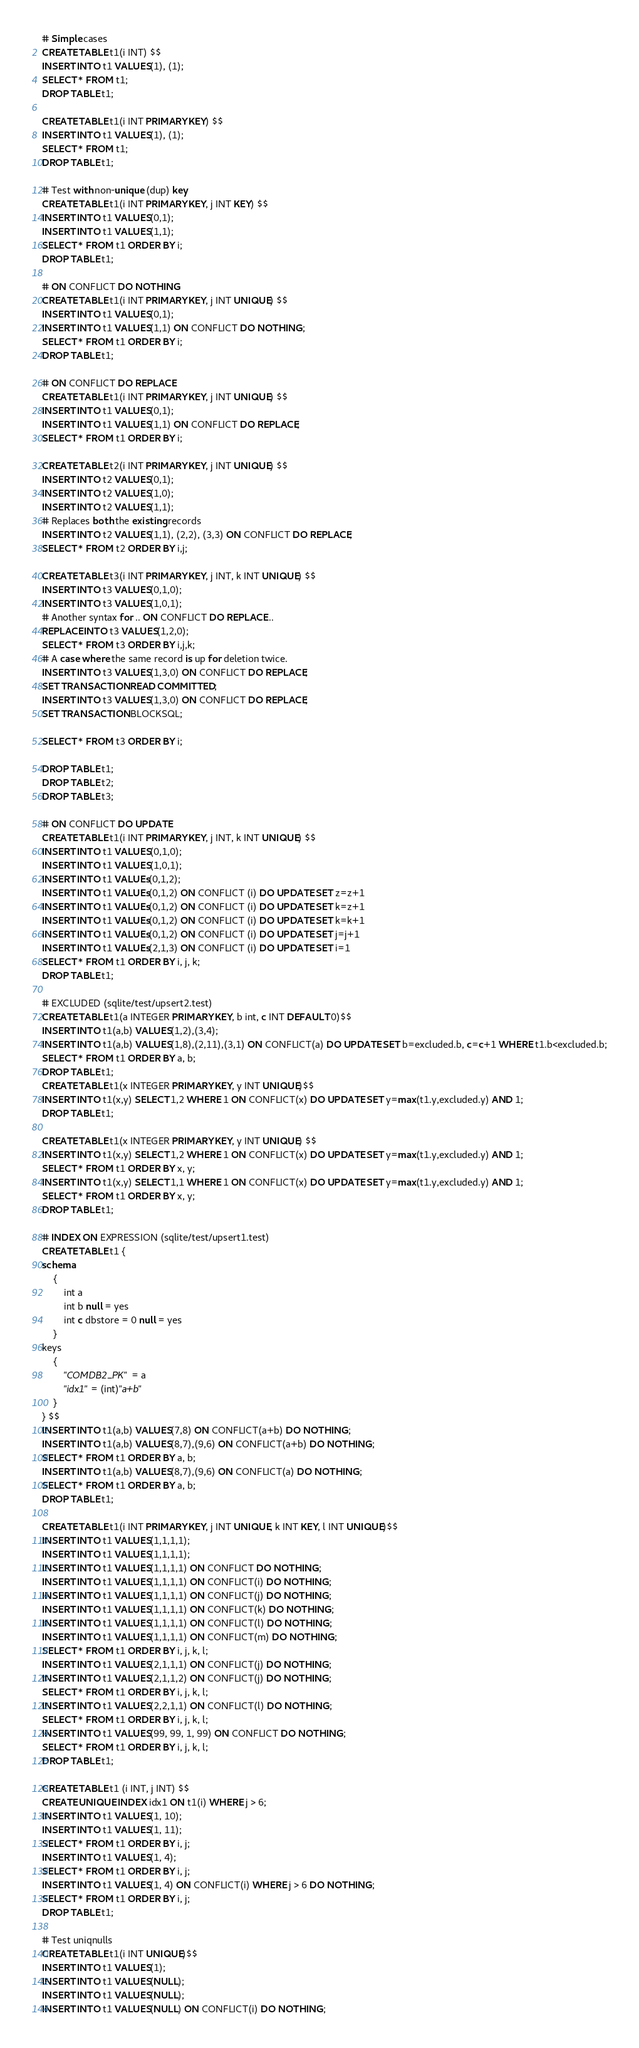<code> <loc_0><loc_0><loc_500><loc_500><_SQL_># Simple cases
CREATE TABLE t1(i INT) $$
INSERT INTO t1 VALUES(1), (1);
SELECT * FROM t1;
DROP TABLE t1;

CREATE TABLE t1(i INT PRIMARY KEY) $$
INSERT INTO t1 VALUES(1), (1);
SELECT * FROM t1;
DROP TABLE t1;

# Test with non-unique (dup) key
CREATE TABLE t1(i INT PRIMARY KEY, j INT KEY) $$
INSERT INTO t1 VALUES(0,1);
INSERT INTO t1 VALUES(1,1);
SELECT * FROM t1 ORDER BY i;
DROP TABLE t1;

# ON CONFLICT DO NOTHING
CREATE TABLE t1(i INT PRIMARY KEY, j INT UNIQUE) $$
INSERT INTO t1 VALUES(0,1);
INSERT INTO t1 VALUES(1,1) ON CONFLICT DO NOTHING;
SELECT * FROM t1 ORDER BY i;
DROP TABLE t1;

# ON CONFLICT DO REPLACE
CREATE TABLE t1(i INT PRIMARY KEY, j INT UNIQUE) $$
INSERT INTO t1 VALUES(0,1);
INSERT INTO t1 VALUES(1,1) ON CONFLICT DO REPLACE;
SELECT * FROM t1 ORDER BY i;

CREATE TABLE t2(i INT PRIMARY KEY, j INT UNIQUE) $$
INSERT INTO t2 VALUES(0,1);
INSERT INTO t2 VALUES(1,0);
INSERT INTO t2 VALUES(1,1);
# Replaces both the existing records
INSERT INTO t2 VALUES(1,1), (2,2), (3,3) ON CONFLICT DO REPLACE;
SELECT * FROM t2 ORDER BY i,j;

CREATE TABLE t3(i INT PRIMARY KEY, j INT, k INT UNIQUE) $$
INSERT INTO t3 VALUES(0,1,0);
INSERT INTO t3 VALUES(1,0,1);
# Another syntax for .. ON CONFLICT DO REPLACE ..
REPLACE INTO t3 VALUES(1,2,0);
SELECT * FROM t3 ORDER BY i,j,k;
# A case where the same record is up for deletion twice.
INSERT INTO t3 VALUES(1,3,0) ON CONFLICT DO REPLACE;
SET TRANSACTION READ COMMITTED;
INSERT INTO t3 VALUES(1,3,0) ON CONFLICT DO REPLACE;
SET TRANSACTION BLOCKSQL;

SELECT * FROM t3 ORDER BY i;

DROP TABLE t1;
DROP TABLE t2;
DROP TABLE t3;

# ON CONFLICT DO UPDATE
CREATE TABLE t1(i INT PRIMARY KEY, j INT, k INT UNIQUE) $$
INSERT INTO t1 VALUES(0,1,0);
INSERT INTO t1 VALUES(1,0,1);
INSERT INTO t1 VALUEs(0,1,2);
INSERT INTO t1 VALUEs(0,1,2) ON CONFLICT (i) DO UPDATE SET z=z+1
INSERT INTO t1 VALUEs(0,1,2) ON CONFLICT (i) DO UPDATE SET k=z+1
INSERT INTO t1 VALUEs(0,1,2) ON CONFLICT (i) DO UPDATE SET k=k+1
INSERT INTO t1 VALUEs(0,1,2) ON CONFLICT (i) DO UPDATE SET j=j+1
INSERT INTO t1 VALUEs(2,1,3) ON CONFLICT (i) DO UPDATE SET i=1
SELECT * FROM t1 ORDER BY i, j, k;
DROP TABLE t1;

# EXCLUDED (sqlite/test/upsert2.test)
CREATE TABLE t1(a INTEGER PRIMARY KEY, b int, c INT DEFAULT 0)$$
INSERT INTO t1(a,b) VALUES(1,2),(3,4);
INSERT INTO t1(a,b) VALUES(1,8),(2,11),(3,1) ON CONFLICT(a) DO UPDATE SET b=excluded.b, c=c+1 WHERE t1.b<excluded.b;
SELECT * FROM t1 ORDER BY a, b;
DROP TABLE t1;
CREATE TABLE t1(x INTEGER PRIMARY KEY, y INT UNIQUE)$$
INSERT INTO t1(x,y) SELECT 1,2 WHERE 1 ON CONFLICT(x) DO UPDATE SET y=max(t1.y,excluded.y) AND 1;
DROP TABLE t1;

CREATE TABLE t1(x INTEGER PRIMARY KEY, y INT UNIQUE) $$
INSERT INTO t1(x,y) SELECT 1,2 WHERE 1 ON CONFLICT(x) DO UPDATE SET y=max(t1.y,excluded.y) AND 1;
SELECT * FROM t1 ORDER BY x, y;
INSERT INTO t1(x,y) SELECT 1,1 WHERE 1 ON CONFLICT(x) DO UPDATE SET y=max(t1.y,excluded.y) AND 1;
SELECT * FROM t1 ORDER BY x, y;
DROP TABLE t1;

# INDEX ON EXPRESSION (sqlite/test/upsert1.test)
CREATE TABLE t1 {
schema
    {
		int a
		int b null = yes
		int c dbstore = 0 null = yes
    }
keys
    {
		"COMDB2_PK" = a
		"idx1" = (int)"a+b"
    }
} $$
INSERT INTO t1(a,b) VALUES(7,8) ON CONFLICT(a+b) DO NOTHING;
INSERT INTO t1(a,b) VALUES(8,7),(9,6) ON CONFLICT(a+b) DO NOTHING;
SELECT * FROM t1 ORDER BY a, b;
INSERT INTO t1(a,b) VALUES(8,7),(9,6) ON CONFLICT(a) DO NOTHING;
SELECT * FROM t1 ORDER BY a, b;
DROP TABLE t1;

CREATE TABLE t1(i INT PRIMARY KEY, j INT UNIQUE, k INT KEY, l INT UNIQUE)$$
INSERT INTO t1 VALUES(1,1,1,1);
INSERT INTO t1 VALUES(1,1,1,1);
INSERT INTO t1 VALUES(1,1,1,1) ON CONFLICT DO NOTHING;
INSERT INTO t1 VALUES(1,1,1,1) ON CONFLICT(i) DO NOTHING;
INSERT INTO t1 VALUES(1,1,1,1) ON CONFLICT(j) DO NOTHING;
INSERT INTO t1 VALUES(1,1,1,1) ON CONFLICT(k) DO NOTHING;
INSERT INTO t1 VALUES(1,1,1,1) ON CONFLICT(l) DO NOTHING;
INSERT INTO t1 VALUES(1,1,1,1) ON CONFLICT(m) DO NOTHING;
SELECT * FROM t1 ORDER BY i, j, k, l;
INSERT INTO t1 VALUES(2,1,1,1) ON CONFLICT(j) DO NOTHING;
INSERT INTO t1 VALUES(2,1,1,2) ON CONFLICT(j) DO NOTHING;
SELECT * FROM t1 ORDER BY i, j, k, l;
INSERT INTO t1 VALUES(2,2,1,1) ON CONFLICT(l) DO NOTHING;
SELECT * FROM t1 ORDER BY i, j, k, l;
INSERT INTO t1 VALUES(99, 99, 1, 99) ON CONFLICT DO NOTHING;
SELECT * FROM t1 ORDER BY i, j, k, l;
DROP TABLE t1;

CREATE TABLE t1 (i INT, j INT) $$
CREATE UNIQUE INDEX idx1 ON t1(i) WHERE j > 6;
INSERT INTO t1 VALUES(1, 10);
INSERT INTO t1 VALUES(1, 11);
SELECT * FROM t1 ORDER BY i, j;
INSERT INTO t1 VALUES(1, 4);
SELECT * FROM t1 ORDER BY i, j;
INSERT INTO t1 VALUES(1, 4) ON CONFLICT(i) WHERE j > 6 DO NOTHING;
SELECT * FROM t1 ORDER BY i, j;
DROP TABLE t1;

# Test uniqnulls
CREATE TABLE t1(i INT UNIQUE)$$
INSERT INTO t1 VALUES(1);
INSERT INTO t1 VALUES(NULL);
INSERT INTO t1 VALUES(NULL);
INSERT INTO t1 VALUES(NULL) ON CONFLICT(i) DO NOTHING;</code> 